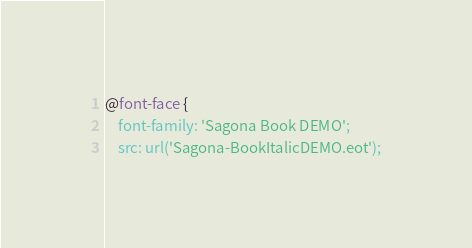<code> <loc_0><loc_0><loc_500><loc_500><_CSS_>@font-face {
    font-family: 'Sagona Book DEMO';
    src: url('Sagona-BookItalicDEMO.eot');</code> 